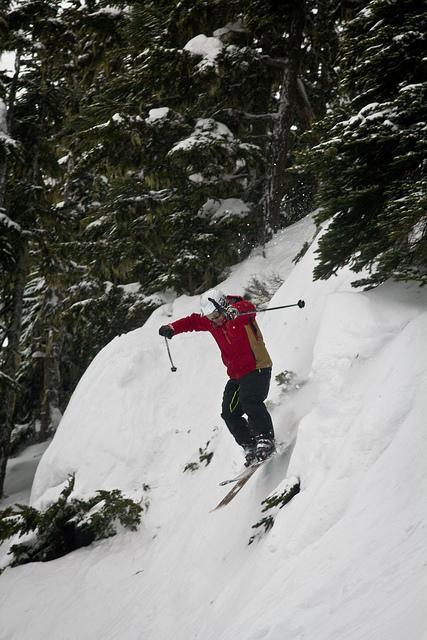How many bikes are there?
Give a very brief answer. 0. 